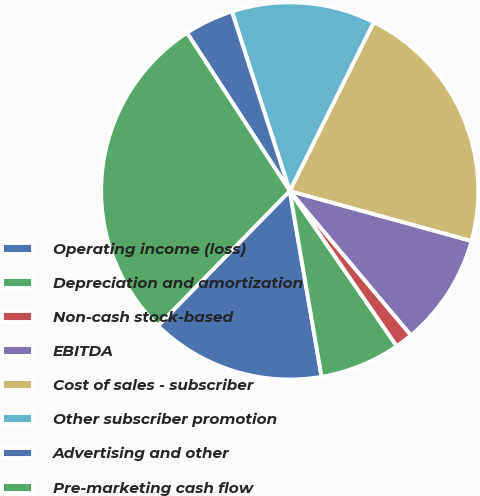Convert chart. <chart><loc_0><loc_0><loc_500><loc_500><pie_chart><fcel>Operating income (loss)<fcel>Depreciation and amortization<fcel>Non-cash stock-based<fcel>EBITDA<fcel>Cost of sales - subscriber<fcel>Other subscriber promotion<fcel>Advertising and other<fcel>Pre-marketing cash flow<nl><fcel>15.01%<fcel>6.91%<fcel>1.51%<fcel>9.61%<fcel>21.93%<fcel>12.31%<fcel>4.21%<fcel>28.51%<nl></chart> 